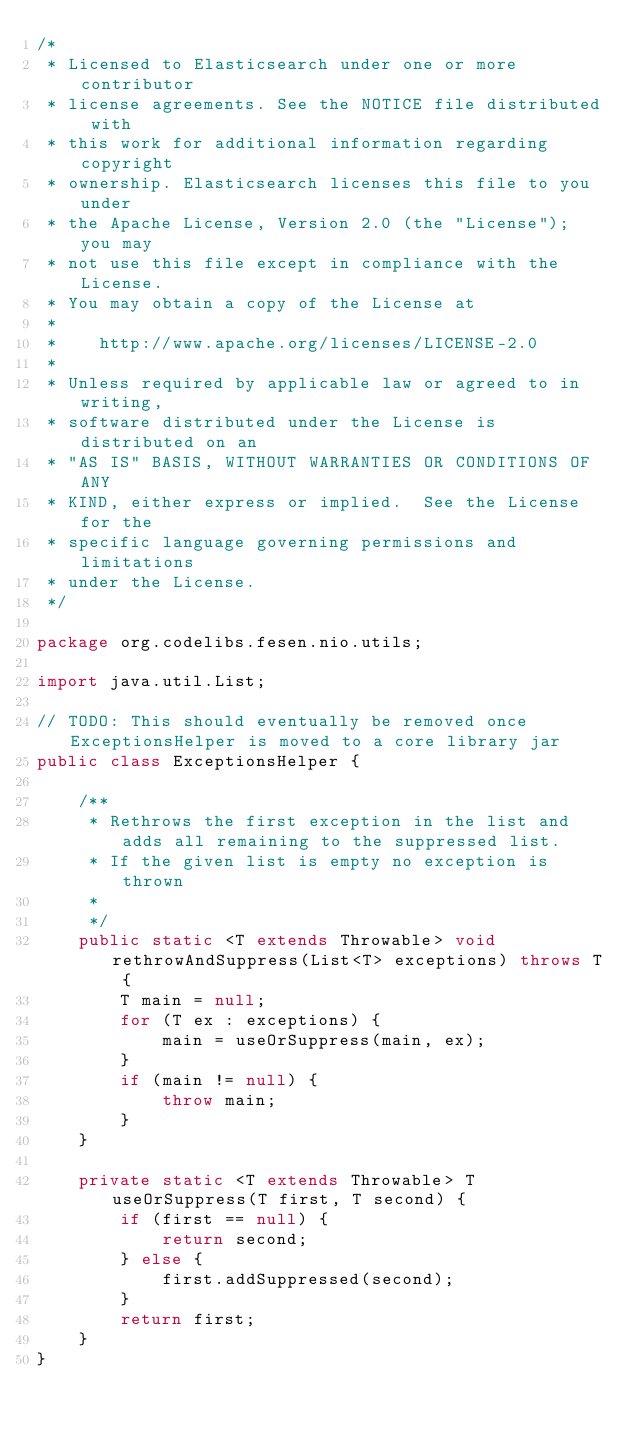Convert code to text. <code><loc_0><loc_0><loc_500><loc_500><_Java_>/*
 * Licensed to Elasticsearch under one or more contributor
 * license agreements. See the NOTICE file distributed with
 * this work for additional information regarding copyright
 * ownership. Elasticsearch licenses this file to you under
 * the Apache License, Version 2.0 (the "License"); you may
 * not use this file except in compliance with the License.
 * You may obtain a copy of the License at
 *
 *    http://www.apache.org/licenses/LICENSE-2.0
 *
 * Unless required by applicable law or agreed to in writing,
 * software distributed under the License is distributed on an
 * "AS IS" BASIS, WITHOUT WARRANTIES OR CONDITIONS OF ANY
 * KIND, either express or implied.  See the License for the
 * specific language governing permissions and limitations
 * under the License.
 */

package org.codelibs.fesen.nio.utils;

import java.util.List;

// TODO: This should eventually be removed once ExceptionsHelper is moved to a core library jar
public class ExceptionsHelper {

    /**
     * Rethrows the first exception in the list and adds all remaining to the suppressed list.
     * If the given list is empty no exception is thrown
     *
     */
    public static <T extends Throwable> void rethrowAndSuppress(List<T> exceptions) throws T {
        T main = null;
        for (T ex : exceptions) {
            main = useOrSuppress(main, ex);
        }
        if (main != null) {
            throw main;
        }
    }

    private static <T extends Throwable> T useOrSuppress(T first, T second) {
        if (first == null) {
            return second;
        } else {
            first.addSuppressed(second);
        }
        return first;
    }
}
</code> 